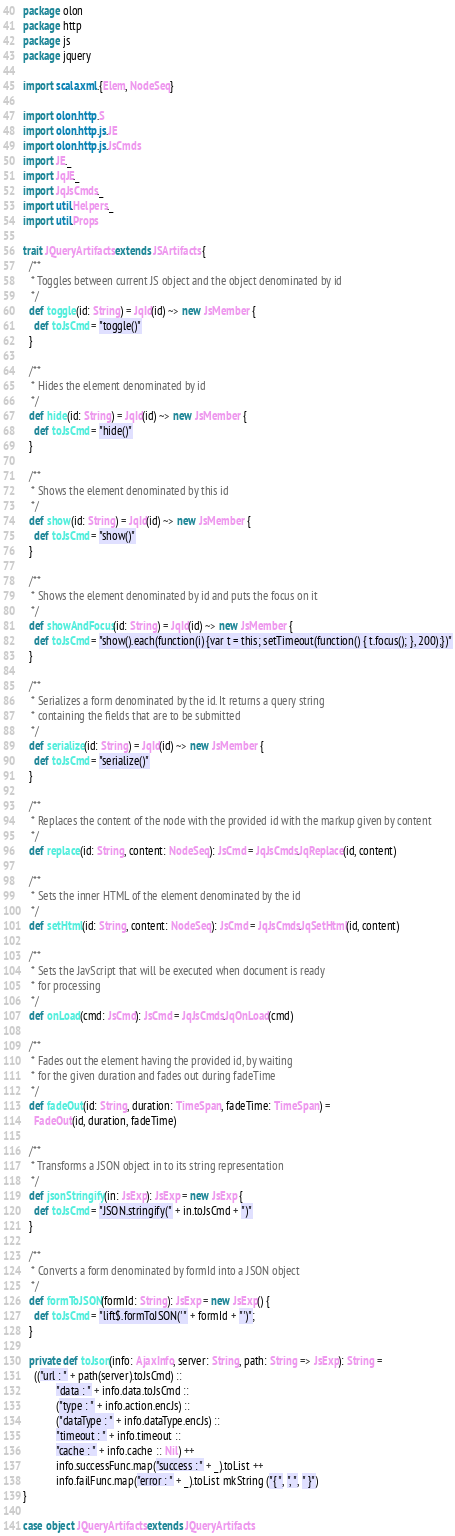<code> <loc_0><loc_0><loc_500><loc_500><_Scala_>package olon
package http
package js
package jquery

import scala.xml.{Elem, NodeSeq}

import olon.http.S
import olon.http.js.JE
import olon.http.js.JsCmds
import JE._
import JqJE._
import JqJsCmds._
import util.Helpers._
import util.Props

trait JQueryArtifacts extends JSArtifacts {
  /**
   * Toggles between current JS object and the object denominated by id
   */
  def toggle(id: String) = JqId(id) ~> new JsMember {
    def toJsCmd = "toggle()"
  }

  /**
   * Hides the element denominated by id
   */
  def hide(id: String) = JqId(id) ~> new JsMember {
    def toJsCmd = "hide()"
  }

  /**
   * Shows the element denominated by this id
   */
  def show(id: String) = JqId(id) ~> new JsMember {
    def toJsCmd = "show()"
  }

  /**
   * Shows the element denominated by id and puts the focus on it
   */
  def showAndFocus(id: String) = JqId(id) ~> new JsMember {
    def toJsCmd = "show().each(function(i) {var t = this; setTimeout(function() { t.focus(); }, 200);})"
  }

  /**
   * Serializes a form denominated by the id. It returns a query string
   * containing the fields that are to be submitted
   */
  def serialize(id: String) = JqId(id) ~> new JsMember {
    def toJsCmd = "serialize()"
  }

  /**
   * Replaces the content of the node with the provided id with the markup given by content
   */
  def replace(id: String, content: NodeSeq): JsCmd = JqJsCmds.JqReplace(id, content)

  /**
   * Sets the inner HTML of the element denominated by the id
   */
  def setHtml(id: String, content: NodeSeq): JsCmd = JqJsCmds.JqSetHtml(id, content)

  /**
   * Sets the JavScript that will be executed when document is ready
   * for processing
   */
  def onLoad(cmd: JsCmd): JsCmd = JqJsCmds.JqOnLoad(cmd)

  /**
   * Fades out the element having the provided id, by waiting
   * for the given duration and fades out during fadeTime
   */
  def fadeOut(id: String, duration: TimeSpan, fadeTime: TimeSpan) =
    FadeOut(id, duration, fadeTime)

  /**
   * Transforms a JSON object in to its string representation
   */
  def jsonStringify(in: JsExp): JsExp = new JsExp {
    def toJsCmd = "JSON.stringify(" + in.toJsCmd + ")"
  }

  /**
   * Converts a form denominated by formId into a JSON object
   */
  def formToJSON(formId: String): JsExp = new JsExp() {
    def toJsCmd = "lift$.formToJSON('" + formId + "')";
  }

  private def toJson(info: AjaxInfo, server: String, path: String => JsExp): String =
    (("url : " + path(server).toJsCmd) ::
            "data : " + info.data.toJsCmd ::
            ("type : " + info.action.encJs) ::
            ("dataType : " + info.dataType.encJs) ::
            "timeout : " + info.timeout ::
            "cache : " + info.cache :: Nil) ++
            info.successFunc.map("success : " + _).toList ++
            info.failFunc.map("error : " + _).toList mkString ("{ ", ", ", " }")
}

case object JQueryArtifacts extends JQueryArtifacts
</code> 